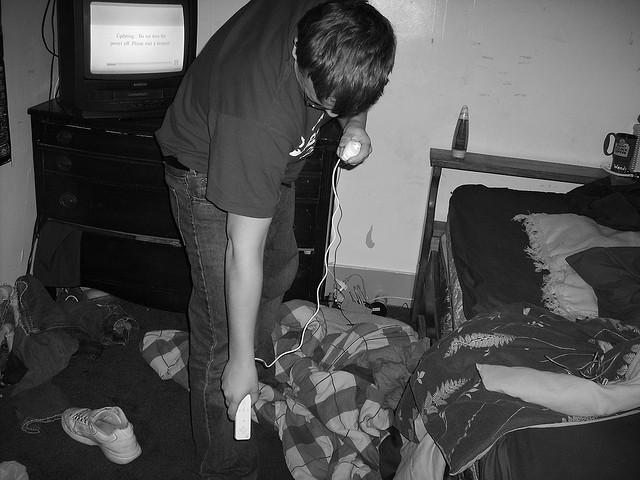Is "The person is against the couch." an appropriate description for the image?
Answer yes or no. No. Is the caption "The person is in front of the tv." a true representation of the image?
Answer yes or no. Yes. 